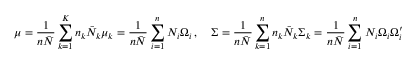Convert formula to latex. <formula><loc_0><loc_0><loc_500><loc_500>\mu = \frac { 1 } { n \bar { N } } \sum _ { k = 1 } ^ { K } n _ { k } \bar { N } _ { k } \mu _ { k } = \frac { 1 } { n \bar { N } } \sum _ { i = 1 } ^ { n } N _ { i } \Omega _ { i } \, , \quad \Sigma = \frac { 1 } { n \bar { N } } \sum _ { k = 1 } ^ { n } n _ { k } \bar { N } _ { k } \Sigma _ { k } = \frac { 1 } { n \bar { N } } \sum _ { i = 1 } ^ { n } N _ { i } \Omega _ { i } \Omega _ { i } ^ { \prime }</formula> 